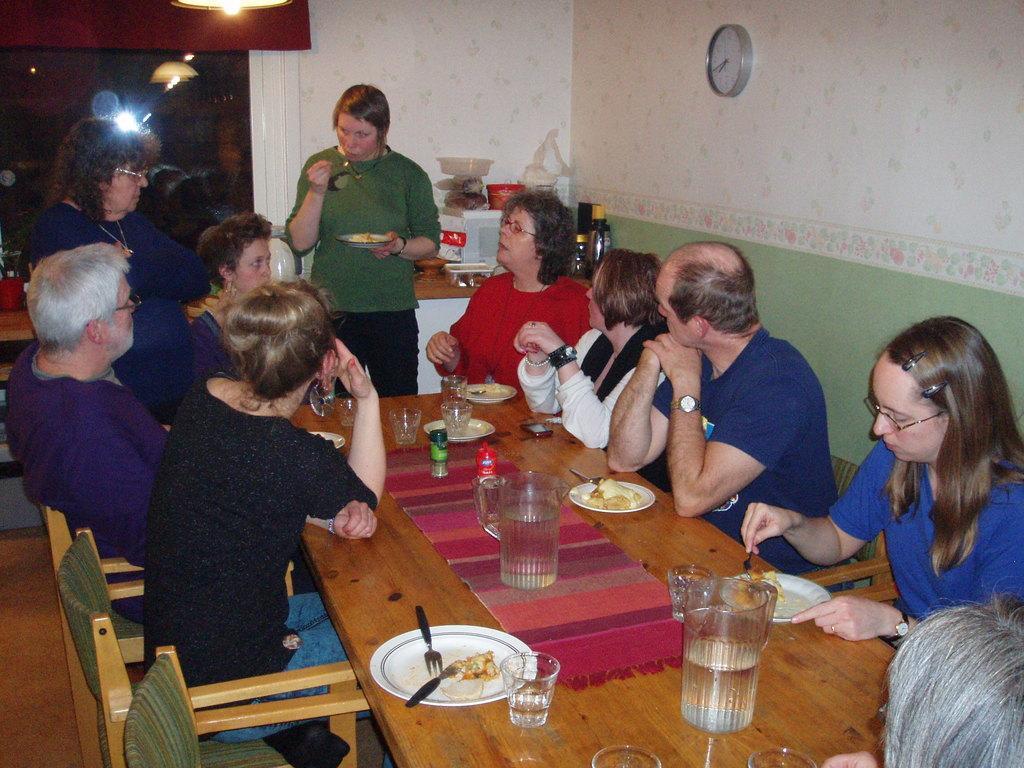Please provide a concise description of this image. In this image, There is a table which is in yellow color on that table there are some glasses and there are some plants which are in white color, There are some people sitting on the chairs around the table, In the background there are two women standing and there is a white color wall, There is a clock on the wall in white color. 